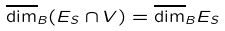<formula> <loc_0><loc_0><loc_500><loc_500>\overline { \dim } _ { B } ( E _ { S } \cap V ) = \overline { \dim } _ { B } E _ { S }</formula> 